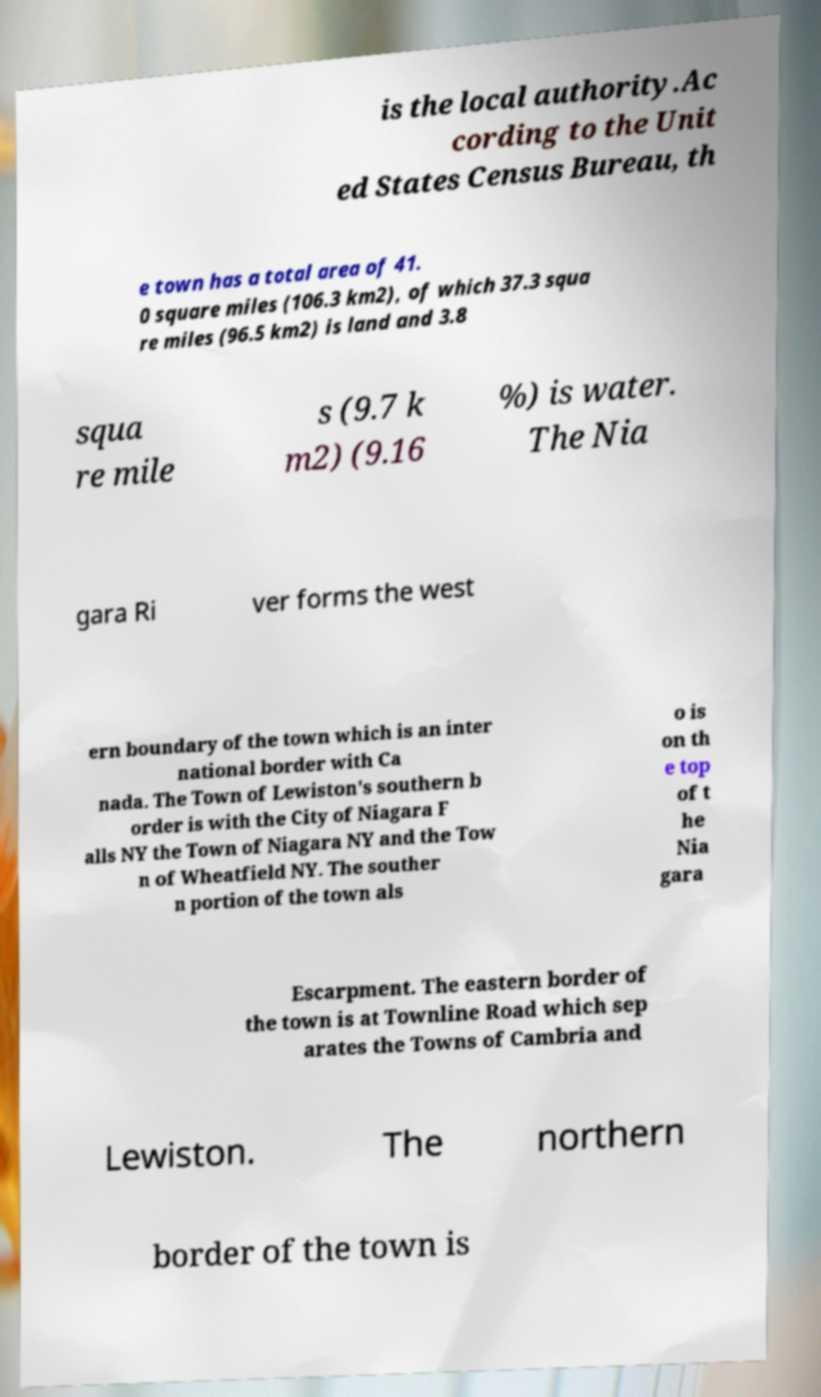I need the written content from this picture converted into text. Can you do that? is the local authority.Ac cording to the Unit ed States Census Bureau, th e town has a total area of 41. 0 square miles (106.3 km2), of which 37.3 squa re miles (96.5 km2) is land and 3.8 squa re mile s (9.7 k m2) (9.16 %) is water. The Nia gara Ri ver forms the west ern boundary of the town which is an inter national border with Ca nada. The Town of Lewiston's southern b order is with the City of Niagara F alls NY the Town of Niagara NY and the Tow n of Wheatfield NY. The souther n portion of the town als o is on th e top of t he Nia gara Escarpment. The eastern border of the town is at Townline Road which sep arates the Towns of Cambria and Lewiston. The northern border of the town is 